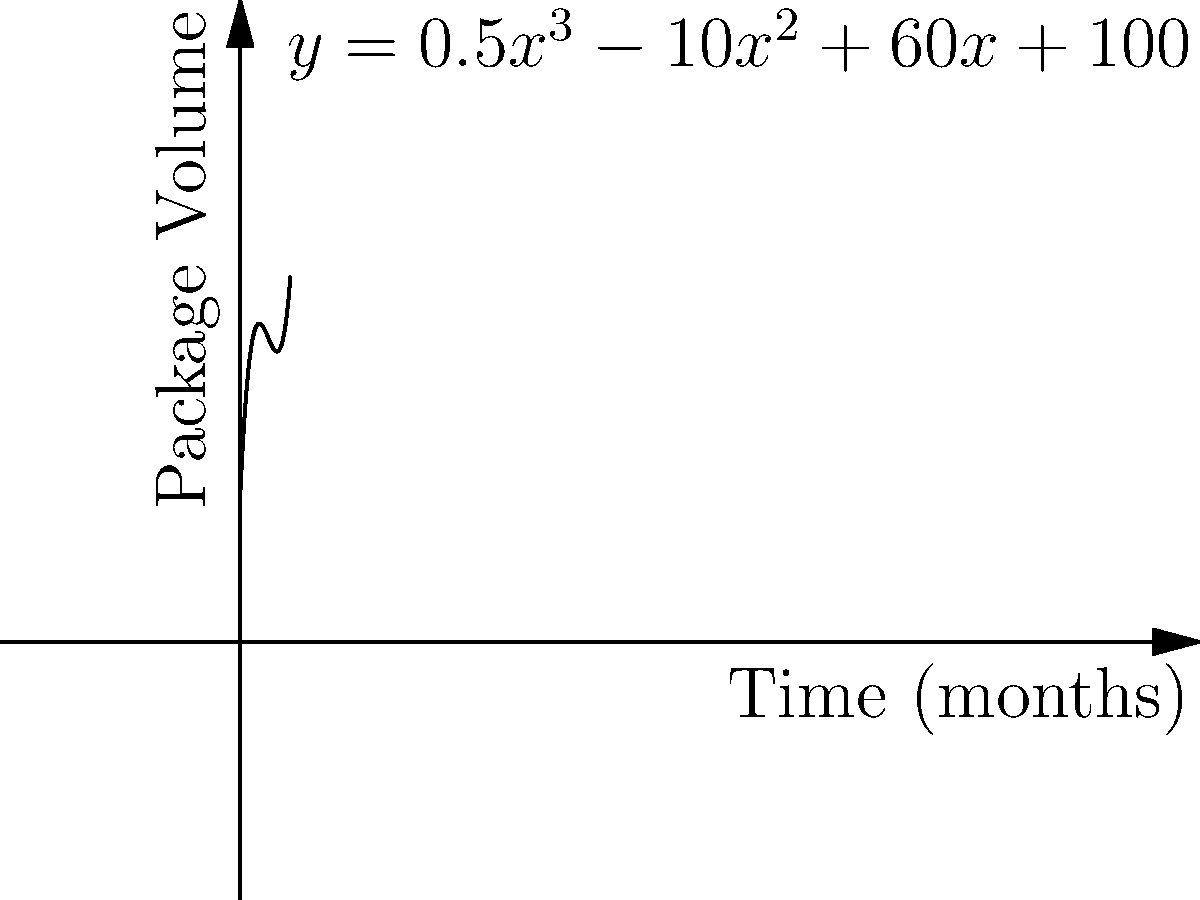The polynomial function $y = 0.5x^3 - 10x^2 + 60x + 100$ represents the monthly package volume trend for your expedited delivery service, where $x$ is the number of months since the beginning of the year and $y$ is the number of packages. At which month does the package volume reach its minimum? To find the minimum point, we need to follow these steps:

1) First, find the derivative of the function:
   $y' = 1.5x^2 - 20x + 60$

2) Set the derivative equal to zero to find critical points:
   $1.5x^2 - 20x + 60 = 0$

3) Solve this quadratic equation:
   $1.5(x^2 - \frac{40}{3}x + 40) = 0$
   $x^2 - \frac{40}{3}x + 40 = 0$

4) Use the quadratic formula: $x = \frac{-b \pm \sqrt{b^2 - 4ac}}{2a}$
   Here, $a=1$, $b=-\frac{40}{3}$, and $c=40$

5) Solving:
   $x = \frac{\frac{40}{3} \pm \sqrt{(\frac{40}{3})^2 - 4(1)(40)}}{2(1)}$
   $x = \frac{\frac{40}{3} \pm \sqrt{\frac{1600}{9} - 160}}{2}$
   $x = \frac{\frac{40}{3} \pm \frac{20}{3}}{2}$

6) This gives us two solutions:
   $x_1 = \frac{\frac{40}{3} + \frac{20}{3}}{2} = 10$
   $x_2 = \frac{\frac{40}{3} - \frac{20}{3}}{2} = \frac{20}{3} \approx 6.67$

7) To determine which is the minimum, we can check the second derivative:
   $y'' = 3x - 20$

8) At $x = \frac{20}{3}$, $y'' > 0$, indicating this is the minimum point.

Therefore, the package volume reaches its minimum at approximately 6.67 months, which rounds to 7 months (July).
Answer: 7 months (July) 